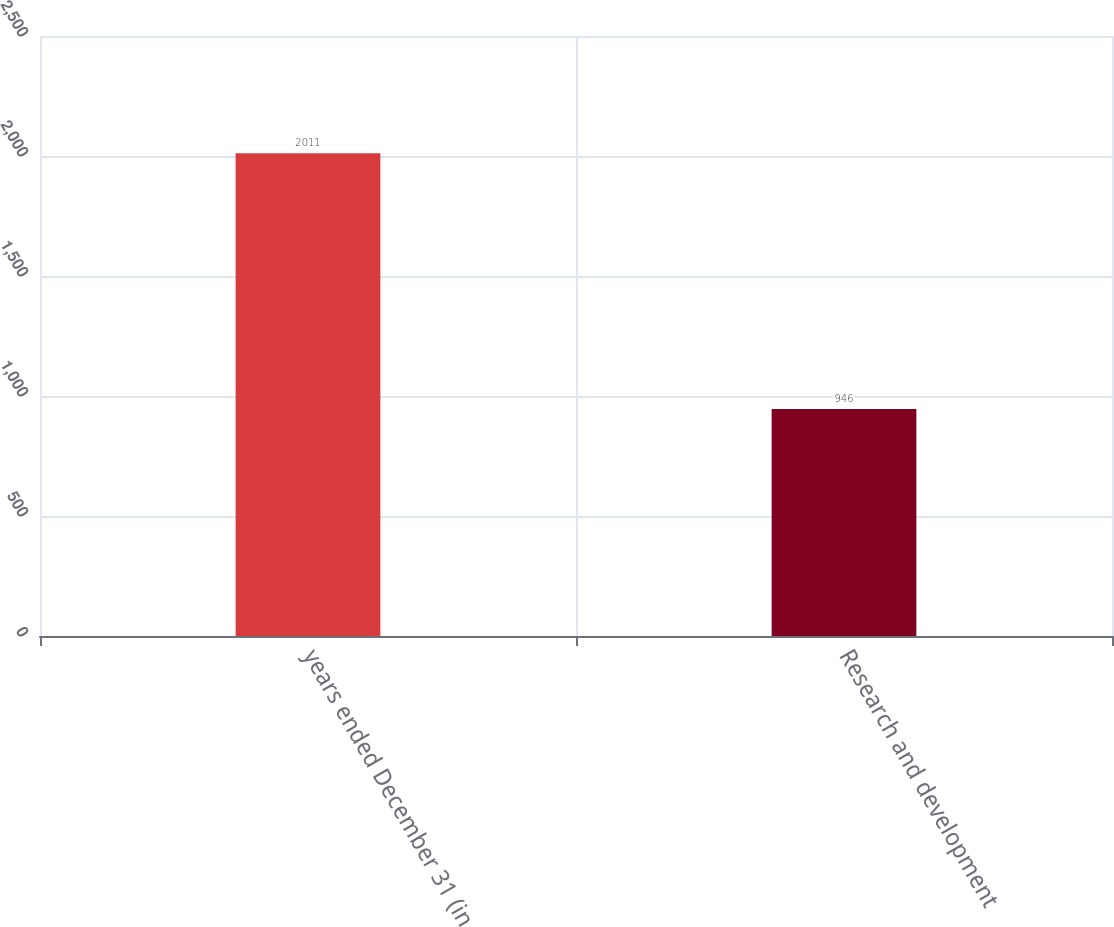Convert chart to OTSL. <chart><loc_0><loc_0><loc_500><loc_500><bar_chart><fcel>years ended December 31 (in<fcel>Research and development<nl><fcel>2011<fcel>946<nl></chart> 